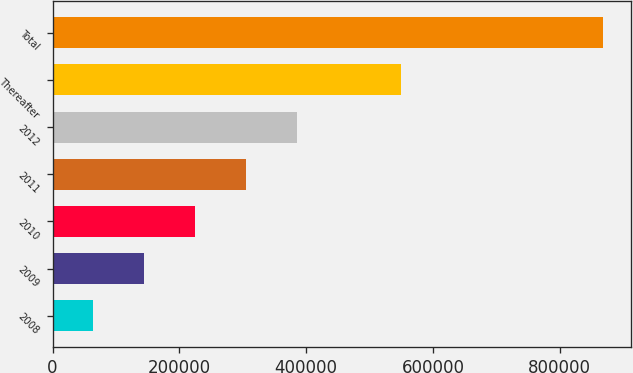Convert chart to OTSL. <chart><loc_0><loc_0><loc_500><loc_500><bar_chart><fcel>2008<fcel>2009<fcel>2010<fcel>2011<fcel>2012<fcel>Thereafter<fcel>Total<nl><fcel>63849<fcel>144364<fcel>224879<fcel>305394<fcel>385909<fcel>549754<fcel>868999<nl></chart> 